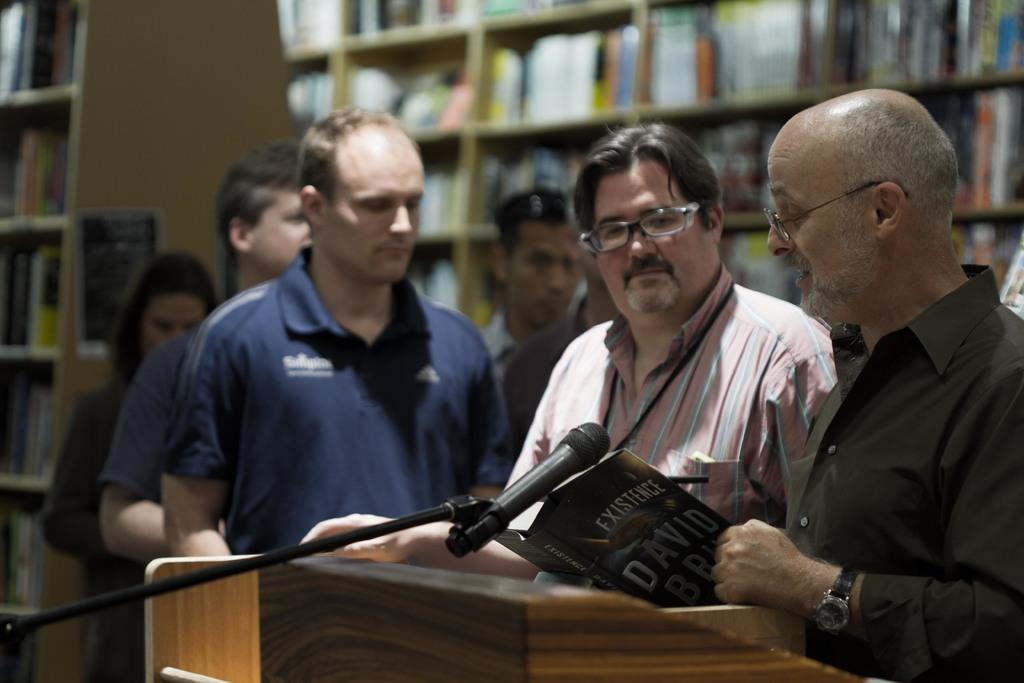<image>
Summarize the visual content of the image. A group of men are reading a book called Existence at a podium. 